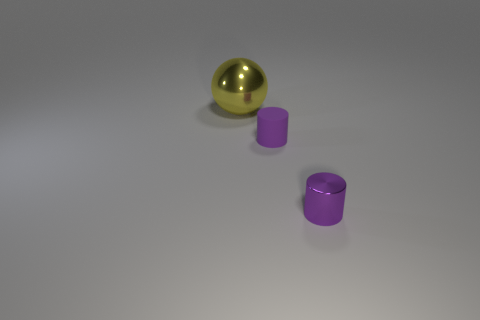Is there any other thing that has the same shape as the big object?
Give a very brief answer. No. How many big yellow metallic things are there?
Your answer should be very brief. 1. Is there any other thing that is the same size as the yellow object?
Make the answer very short. No. There is a metallic object that is to the right of the big yellow ball; is its size the same as the purple thing that is behind the tiny purple metallic cylinder?
Ensure brevity in your answer.  Yes. Is the number of purple matte cylinders less than the number of small red cylinders?
Make the answer very short. No. What number of rubber things are blue spheres or small things?
Your answer should be compact. 1. There is a tiny object that is on the left side of the purple metallic cylinder; are there any purple cylinders to the right of it?
Ensure brevity in your answer.  Yes. Is the material of the small purple cylinder that is in front of the small purple matte object the same as the big sphere?
Offer a very short reply. Yes. How many other objects are there of the same color as the large ball?
Give a very brief answer. 0. Do the tiny metallic cylinder and the rubber cylinder have the same color?
Provide a short and direct response. Yes. 